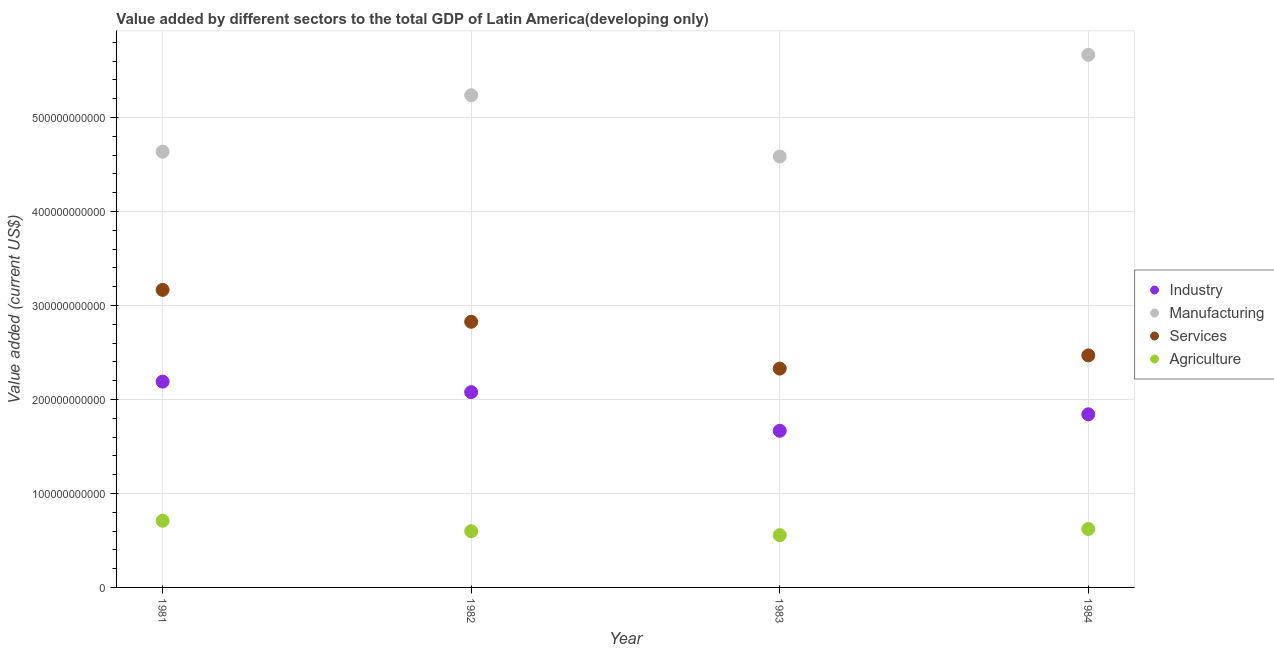What is the value added by services sector in 1982?
Give a very brief answer. 2.83e+11. Across all years, what is the maximum value added by industrial sector?
Provide a succinct answer. 2.19e+11. Across all years, what is the minimum value added by industrial sector?
Your response must be concise. 1.67e+11. In which year was the value added by manufacturing sector minimum?
Your answer should be very brief. 1983. What is the total value added by industrial sector in the graph?
Provide a short and direct response. 7.77e+11. What is the difference between the value added by industrial sector in 1981 and that in 1983?
Keep it short and to the point. 5.23e+1. What is the difference between the value added by manufacturing sector in 1982 and the value added by services sector in 1983?
Offer a terse response. 2.91e+11. What is the average value added by agricultural sector per year?
Ensure brevity in your answer.  6.21e+1. In the year 1984, what is the difference between the value added by agricultural sector and value added by manufacturing sector?
Ensure brevity in your answer.  -5.04e+11. In how many years, is the value added by services sector greater than 520000000000 US$?
Ensure brevity in your answer.  0. What is the ratio of the value added by industrial sector in 1981 to that in 1984?
Make the answer very short. 1.19. Is the value added by industrial sector in 1982 less than that in 1983?
Provide a short and direct response. No. Is the difference between the value added by industrial sector in 1982 and 1983 greater than the difference between the value added by agricultural sector in 1982 and 1983?
Your answer should be compact. Yes. What is the difference between the highest and the second highest value added by manufacturing sector?
Provide a succinct answer. 4.30e+1. What is the difference between the highest and the lowest value added by manufacturing sector?
Provide a short and direct response. 1.08e+11. Is the sum of the value added by services sector in 1982 and 1983 greater than the maximum value added by agricultural sector across all years?
Offer a terse response. Yes. Is it the case that in every year, the sum of the value added by manufacturing sector and value added by services sector is greater than the sum of value added by agricultural sector and value added by industrial sector?
Offer a very short reply. Yes. Is it the case that in every year, the sum of the value added by industrial sector and value added by manufacturing sector is greater than the value added by services sector?
Offer a terse response. Yes. How many dotlines are there?
Your answer should be very brief. 4. What is the difference between two consecutive major ticks on the Y-axis?
Give a very brief answer. 1.00e+11. Does the graph contain any zero values?
Your answer should be very brief. No. Does the graph contain grids?
Your answer should be compact. Yes. Where does the legend appear in the graph?
Ensure brevity in your answer.  Center right. What is the title of the graph?
Provide a succinct answer. Value added by different sectors to the total GDP of Latin America(developing only). Does "Social Assistance" appear as one of the legend labels in the graph?
Keep it short and to the point. No. What is the label or title of the Y-axis?
Offer a very short reply. Value added (current US$). What is the Value added (current US$) in Industry in 1981?
Your answer should be compact. 2.19e+11. What is the Value added (current US$) in Manufacturing in 1981?
Give a very brief answer. 4.63e+11. What is the Value added (current US$) of Services in 1981?
Your answer should be compact. 3.17e+11. What is the Value added (current US$) of Agriculture in 1981?
Your answer should be very brief. 7.09e+1. What is the Value added (current US$) in Industry in 1982?
Your answer should be very brief. 2.08e+11. What is the Value added (current US$) of Manufacturing in 1982?
Provide a short and direct response. 5.24e+11. What is the Value added (current US$) of Services in 1982?
Keep it short and to the point. 2.83e+11. What is the Value added (current US$) of Agriculture in 1982?
Give a very brief answer. 5.98e+1. What is the Value added (current US$) of Industry in 1983?
Offer a terse response. 1.67e+11. What is the Value added (current US$) in Manufacturing in 1983?
Keep it short and to the point. 4.58e+11. What is the Value added (current US$) of Services in 1983?
Your response must be concise. 2.33e+11. What is the Value added (current US$) of Agriculture in 1983?
Keep it short and to the point. 5.56e+1. What is the Value added (current US$) in Industry in 1984?
Offer a terse response. 1.84e+11. What is the Value added (current US$) of Manufacturing in 1984?
Offer a very short reply. 5.67e+11. What is the Value added (current US$) of Services in 1984?
Your answer should be compact. 2.47e+11. What is the Value added (current US$) of Agriculture in 1984?
Offer a very short reply. 6.22e+1. Across all years, what is the maximum Value added (current US$) of Industry?
Provide a short and direct response. 2.19e+11. Across all years, what is the maximum Value added (current US$) of Manufacturing?
Your response must be concise. 5.67e+11. Across all years, what is the maximum Value added (current US$) of Services?
Provide a short and direct response. 3.17e+11. Across all years, what is the maximum Value added (current US$) of Agriculture?
Make the answer very short. 7.09e+1. Across all years, what is the minimum Value added (current US$) in Industry?
Make the answer very short. 1.67e+11. Across all years, what is the minimum Value added (current US$) of Manufacturing?
Ensure brevity in your answer.  4.58e+11. Across all years, what is the minimum Value added (current US$) of Services?
Ensure brevity in your answer.  2.33e+11. Across all years, what is the minimum Value added (current US$) of Agriculture?
Provide a succinct answer. 5.56e+1. What is the total Value added (current US$) in Industry in the graph?
Your answer should be compact. 7.77e+11. What is the total Value added (current US$) of Manufacturing in the graph?
Provide a short and direct response. 2.01e+12. What is the total Value added (current US$) of Services in the graph?
Give a very brief answer. 1.08e+12. What is the total Value added (current US$) in Agriculture in the graph?
Provide a short and direct response. 2.48e+11. What is the difference between the Value added (current US$) of Industry in 1981 and that in 1982?
Keep it short and to the point. 1.12e+1. What is the difference between the Value added (current US$) of Manufacturing in 1981 and that in 1982?
Ensure brevity in your answer.  -6.01e+1. What is the difference between the Value added (current US$) of Services in 1981 and that in 1982?
Ensure brevity in your answer.  3.39e+1. What is the difference between the Value added (current US$) in Agriculture in 1981 and that in 1982?
Provide a succinct answer. 1.11e+1. What is the difference between the Value added (current US$) in Industry in 1981 and that in 1983?
Your response must be concise. 5.23e+1. What is the difference between the Value added (current US$) of Manufacturing in 1981 and that in 1983?
Offer a terse response. 5.09e+09. What is the difference between the Value added (current US$) of Services in 1981 and that in 1983?
Your answer should be very brief. 8.37e+1. What is the difference between the Value added (current US$) in Agriculture in 1981 and that in 1983?
Offer a terse response. 1.53e+1. What is the difference between the Value added (current US$) of Industry in 1981 and that in 1984?
Ensure brevity in your answer.  3.48e+1. What is the difference between the Value added (current US$) in Manufacturing in 1981 and that in 1984?
Offer a very short reply. -1.03e+11. What is the difference between the Value added (current US$) of Services in 1981 and that in 1984?
Offer a very short reply. 6.97e+1. What is the difference between the Value added (current US$) in Agriculture in 1981 and that in 1984?
Provide a short and direct response. 8.73e+09. What is the difference between the Value added (current US$) in Industry in 1982 and that in 1983?
Offer a very short reply. 4.11e+1. What is the difference between the Value added (current US$) in Manufacturing in 1982 and that in 1983?
Your answer should be very brief. 6.52e+1. What is the difference between the Value added (current US$) in Services in 1982 and that in 1983?
Offer a very short reply. 4.98e+1. What is the difference between the Value added (current US$) in Agriculture in 1982 and that in 1983?
Make the answer very short. 4.20e+09. What is the difference between the Value added (current US$) in Industry in 1982 and that in 1984?
Offer a terse response. 2.35e+1. What is the difference between the Value added (current US$) in Manufacturing in 1982 and that in 1984?
Your response must be concise. -4.30e+1. What is the difference between the Value added (current US$) of Services in 1982 and that in 1984?
Offer a very short reply. 3.58e+1. What is the difference between the Value added (current US$) of Agriculture in 1982 and that in 1984?
Offer a very short reply. -2.38e+09. What is the difference between the Value added (current US$) in Industry in 1983 and that in 1984?
Offer a terse response. -1.76e+1. What is the difference between the Value added (current US$) of Manufacturing in 1983 and that in 1984?
Provide a short and direct response. -1.08e+11. What is the difference between the Value added (current US$) in Services in 1983 and that in 1984?
Offer a very short reply. -1.40e+1. What is the difference between the Value added (current US$) of Agriculture in 1983 and that in 1984?
Your response must be concise. -6.58e+09. What is the difference between the Value added (current US$) of Industry in 1981 and the Value added (current US$) of Manufacturing in 1982?
Give a very brief answer. -3.05e+11. What is the difference between the Value added (current US$) of Industry in 1981 and the Value added (current US$) of Services in 1982?
Your answer should be very brief. -6.36e+1. What is the difference between the Value added (current US$) in Industry in 1981 and the Value added (current US$) in Agriculture in 1982?
Your response must be concise. 1.59e+11. What is the difference between the Value added (current US$) in Manufacturing in 1981 and the Value added (current US$) in Services in 1982?
Give a very brief answer. 1.81e+11. What is the difference between the Value added (current US$) in Manufacturing in 1981 and the Value added (current US$) in Agriculture in 1982?
Ensure brevity in your answer.  4.04e+11. What is the difference between the Value added (current US$) in Services in 1981 and the Value added (current US$) in Agriculture in 1982?
Your answer should be very brief. 2.57e+11. What is the difference between the Value added (current US$) in Industry in 1981 and the Value added (current US$) in Manufacturing in 1983?
Give a very brief answer. -2.39e+11. What is the difference between the Value added (current US$) of Industry in 1981 and the Value added (current US$) of Services in 1983?
Provide a succinct answer. -1.38e+1. What is the difference between the Value added (current US$) in Industry in 1981 and the Value added (current US$) in Agriculture in 1983?
Your answer should be compact. 1.63e+11. What is the difference between the Value added (current US$) of Manufacturing in 1981 and the Value added (current US$) of Services in 1983?
Your answer should be very brief. 2.31e+11. What is the difference between the Value added (current US$) of Manufacturing in 1981 and the Value added (current US$) of Agriculture in 1983?
Provide a short and direct response. 4.08e+11. What is the difference between the Value added (current US$) of Services in 1981 and the Value added (current US$) of Agriculture in 1983?
Provide a short and direct response. 2.61e+11. What is the difference between the Value added (current US$) in Industry in 1981 and the Value added (current US$) in Manufacturing in 1984?
Provide a short and direct response. -3.48e+11. What is the difference between the Value added (current US$) of Industry in 1981 and the Value added (current US$) of Services in 1984?
Give a very brief answer. -2.79e+1. What is the difference between the Value added (current US$) in Industry in 1981 and the Value added (current US$) in Agriculture in 1984?
Offer a very short reply. 1.57e+11. What is the difference between the Value added (current US$) of Manufacturing in 1981 and the Value added (current US$) of Services in 1984?
Your answer should be very brief. 2.17e+11. What is the difference between the Value added (current US$) in Manufacturing in 1981 and the Value added (current US$) in Agriculture in 1984?
Keep it short and to the point. 4.01e+11. What is the difference between the Value added (current US$) of Services in 1981 and the Value added (current US$) of Agriculture in 1984?
Ensure brevity in your answer.  2.54e+11. What is the difference between the Value added (current US$) in Industry in 1982 and the Value added (current US$) in Manufacturing in 1983?
Offer a terse response. -2.51e+11. What is the difference between the Value added (current US$) of Industry in 1982 and the Value added (current US$) of Services in 1983?
Your response must be concise. -2.51e+1. What is the difference between the Value added (current US$) of Industry in 1982 and the Value added (current US$) of Agriculture in 1983?
Give a very brief answer. 1.52e+11. What is the difference between the Value added (current US$) of Manufacturing in 1982 and the Value added (current US$) of Services in 1983?
Make the answer very short. 2.91e+11. What is the difference between the Value added (current US$) in Manufacturing in 1982 and the Value added (current US$) in Agriculture in 1983?
Offer a terse response. 4.68e+11. What is the difference between the Value added (current US$) of Services in 1982 and the Value added (current US$) of Agriculture in 1983?
Offer a terse response. 2.27e+11. What is the difference between the Value added (current US$) of Industry in 1982 and the Value added (current US$) of Manufacturing in 1984?
Make the answer very short. -3.59e+11. What is the difference between the Value added (current US$) in Industry in 1982 and the Value added (current US$) in Services in 1984?
Offer a very short reply. -3.91e+1. What is the difference between the Value added (current US$) of Industry in 1982 and the Value added (current US$) of Agriculture in 1984?
Offer a very short reply. 1.46e+11. What is the difference between the Value added (current US$) of Manufacturing in 1982 and the Value added (current US$) of Services in 1984?
Offer a terse response. 2.77e+11. What is the difference between the Value added (current US$) of Manufacturing in 1982 and the Value added (current US$) of Agriculture in 1984?
Your answer should be compact. 4.61e+11. What is the difference between the Value added (current US$) in Services in 1982 and the Value added (current US$) in Agriculture in 1984?
Provide a short and direct response. 2.20e+11. What is the difference between the Value added (current US$) of Industry in 1983 and the Value added (current US$) of Manufacturing in 1984?
Give a very brief answer. -4.00e+11. What is the difference between the Value added (current US$) in Industry in 1983 and the Value added (current US$) in Services in 1984?
Provide a short and direct response. -8.02e+1. What is the difference between the Value added (current US$) of Industry in 1983 and the Value added (current US$) of Agriculture in 1984?
Offer a very short reply. 1.04e+11. What is the difference between the Value added (current US$) in Manufacturing in 1983 and the Value added (current US$) in Services in 1984?
Offer a very short reply. 2.12e+11. What is the difference between the Value added (current US$) in Manufacturing in 1983 and the Value added (current US$) in Agriculture in 1984?
Make the answer very short. 3.96e+11. What is the difference between the Value added (current US$) in Services in 1983 and the Value added (current US$) in Agriculture in 1984?
Your response must be concise. 1.71e+11. What is the average Value added (current US$) in Industry per year?
Make the answer very short. 1.94e+11. What is the average Value added (current US$) of Manufacturing per year?
Provide a succinct answer. 5.03e+11. What is the average Value added (current US$) in Services per year?
Provide a succinct answer. 2.70e+11. What is the average Value added (current US$) in Agriculture per year?
Offer a terse response. 6.21e+1. In the year 1981, what is the difference between the Value added (current US$) of Industry and Value added (current US$) of Manufacturing?
Keep it short and to the point. -2.45e+11. In the year 1981, what is the difference between the Value added (current US$) of Industry and Value added (current US$) of Services?
Provide a succinct answer. -9.76e+1. In the year 1981, what is the difference between the Value added (current US$) in Industry and Value added (current US$) in Agriculture?
Your response must be concise. 1.48e+11. In the year 1981, what is the difference between the Value added (current US$) in Manufacturing and Value added (current US$) in Services?
Offer a terse response. 1.47e+11. In the year 1981, what is the difference between the Value added (current US$) of Manufacturing and Value added (current US$) of Agriculture?
Offer a very short reply. 3.93e+11. In the year 1981, what is the difference between the Value added (current US$) of Services and Value added (current US$) of Agriculture?
Your response must be concise. 2.46e+11. In the year 1982, what is the difference between the Value added (current US$) of Industry and Value added (current US$) of Manufacturing?
Your answer should be very brief. -3.16e+11. In the year 1982, what is the difference between the Value added (current US$) of Industry and Value added (current US$) of Services?
Give a very brief answer. -7.49e+1. In the year 1982, what is the difference between the Value added (current US$) in Industry and Value added (current US$) in Agriculture?
Offer a terse response. 1.48e+11. In the year 1982, what is the difference between the Value added (current US$) of Manufacturing and Value added (current US$) of Services?
Provide a short and direct response. 2.41e+11. In the year 1982, what is the difference between the Value added (current US$) in Manufacturing and Value added (current US$) in Agriculture?
Offer a terse response. 4.64e+11. In the year 1982, what is the difference between the Value added (current US$) of Services and Value added (current US$) of Agriculture?
Provide a succinct answer. 2.23e+11. In the year 1983, what is the difference between the Value added (current US$) of Industry and Value added (current US$) of Manufacturing?
Provide a short and direct response. -2.92e+11. In the year 1983, what is the difference between the Value added (current US$) of Industry and Value added (current US$) of Services?
Your response must be concise. -6.62e+1. In the year 1983, what is the difference between the Value added (current US$) in Industry and Value added (current US$) in Agriculture?
Keep it short and to the point. 1.11e+11. In the year 1983, what is the difference between the Value added (current US$) of Manufacturing and Value added (current US$) of Services?
Give a very brief answer. 2.26e+11. In the year 1983, what is the difference between the Value added (current US$) in Manufacturing and Value added (current US$) in Agriculture?
Make the answer very short. 4.03e+11. In the year 1983, what is the difference between the Value added (current US$) in Services and Value added (current US$) in Agriculture?
Offer a terse response. 1.77e+11. In the year 1984, what is the difference between the Value added (current US$) in Industry and Value added (current US$) in Manufacturing?
Your response must be concise. -3.82e+11. In the year 1984, what is the difference between the Value added (current US$) of Industry and Value added (current US$) of Services?
Your response must be concise. -6.27e+1. In the year 1984, what is the difference between the Value added (current US$) in Industry and Value added (current US$) in Agriculture?
Make the answer very short. 1.22e+11. In the year 1984, what is the difference between the Value added (current US$) of Manufacturing and Value added (current US$) of Services?
Offer a very short reply. 3.20e+11. In the year 1984, what is the difference between the Value added (current US$) in Manufacturing and Value added (current US$) in Agriculture?
Give a very brief answer. 5.04e+11. In the year 1984, what is the difference between the Value added (current US$) in Services and Value added (current US$) in Agriculture?
Your response must be concise. 1.85e+11. What is the ratio of the Value added (current US$) in Industry in 1981 to that in 1982?
Keep it short and to the point. 1.05. What is the ratio of the Value added (current US$) in Manufacturing in 1981 to that in 1982?
Offer a very short reply. 0.89. What is the ratio of the Value added (current US$) of Services in 1981 to that in 1982?
Provide a succinct answer. 1.12. What is the ratio of the Value added (current US$) in Agriculture in 1981 to that in 1982?
Keep it short and to the point. 1.19. What is the ratio of the Value added (current US$) in Industry in 1981 to that in 1983?
Provide a succinct answer. 1.31. What is the ratio of the Value added (current US$) of Manufacturing in 1981 to that in 1983?
Provide a short and direct response. 1.01. What is the ratio of the Value added (current US$) of Services in 1981 to that in 1983?
Your answer should be very brief. 1.36. What is the ratio of the Value added (current US$) of Agriculture in 1981 to that in 1983?
Your answer should be very brief. 1.28. What is the ratio of the Value added (current US$) of Industry in 1981 to that in 1984?
Your response must be concise. 1.19. What is the ratio of the Value added (current US$) of Manufacturing in 1981 to that in 1984?
Offer a very short reply. 0.82. What is the ratio of the Value added (current US$) of Services in 1981 to that in 1984?
Ensure brevity in your answer.  1.28. What is the ratio of the Value added (current US$) in Agriculture in 1981 to that in 1984?
Offer a terse response. 1.14. What is the ratio of the Value added (current US$) of Industry in 1982 to that in 1983?
Keep it short and to the point. 1.25. What is the ratio of the Value added (current US$) in Manufacturing in 1982 to that in 1983?
Your answer should be very brief. 1.14. What is the ratio of the Value added (current US$) of Services in 1982 to that in 1983?
Give a very brief answer. 1.21. What is the ratio of the Value added (current US$) of Agriculture in 1982 to that in 1983?
Offer a terse response. 1.08. What is the ratio of the Value added (current US$) in Industry in 1982 to that in 1984?
Your response must be concise. 1.13. What is the ratio of the Value added (current US$) in Manufacturing in 1982 to that in 1984?
Ensure brevity in your answer.  0.92. What is the ratio of the Value added (current US$) in Services in 1982 to that in 1984?
Ensure brevity in your answer.  1.14. What is the ratio of the Value added (current US$) of Agriculture in 1982 to that in 1984?
Keep it short and to the point. 0.96. What is the ratio of the Value added (current US$) in Industry in 1983 to that in 1984?
Give a very brief answer. 0.9. What is the ratio of the Value added (current US$) of Manufacturing in 1983 to that in 1984?
Provide a short and direct response. 0.81. What is the ratio of the Value added (current US$) in Services in 1983 to that in 1984?
Your answer should be compact. 0.94. What is the ratio of the Value added (current US$) of Agriculture in 1983 to that in 1984?
Keep it short and to the point. 0.89. What is the difference between the highest and the second highest Value added (current US$) in Industry?
Ensure brevity in your answer.  1.12e+1. What is the difference between the highest and the second highest Value added (current US$) in Manufacturing?
Keep it short and to the point. 4.30e+1. What is the difference between the highest and the second highest Value added (current US$) of Services?
Keep it short and to the point. 3.39e+1. What is the difference between the highest and the second highest Value added (current US$) of Agriculture?
Make the answer very short. 8.73e+09. What is the difference between the highest and the lowest Value added (current US$) of Industry?
Provide a short and direct response. 5.23e+1. What is the difference between the highest and the lowest Value added (current US$) in Manufacturing?
Give a very brief answer. 1.08e+11. What is the difference between the highest and the lowest Value added (current US$) of Services?
Your response must be concise. 8.37e+1. What is the difference between the highest and the lowest Value added (current US$) of Agriculture?
Provide a short and direct response. 1.53e+1. 